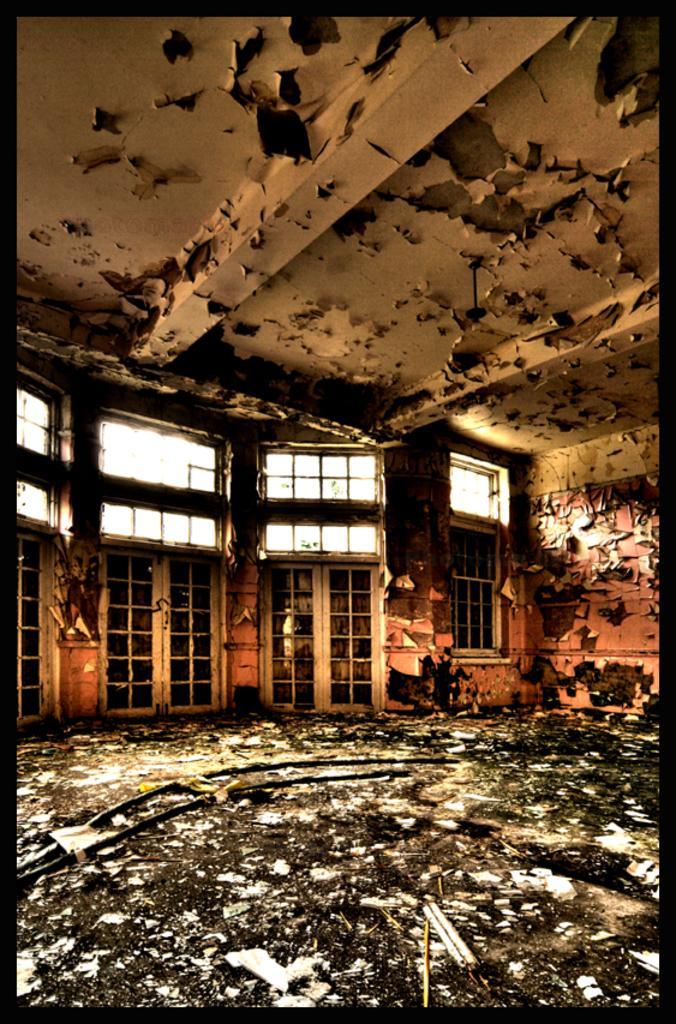In one or two sentences, can you explain what this image depicts? This is a photo. This is an old building. In this picture we can see the doors, window, wall. At the bottom of the image we can see the floor, rods. At the top of the image we can see the roof. 